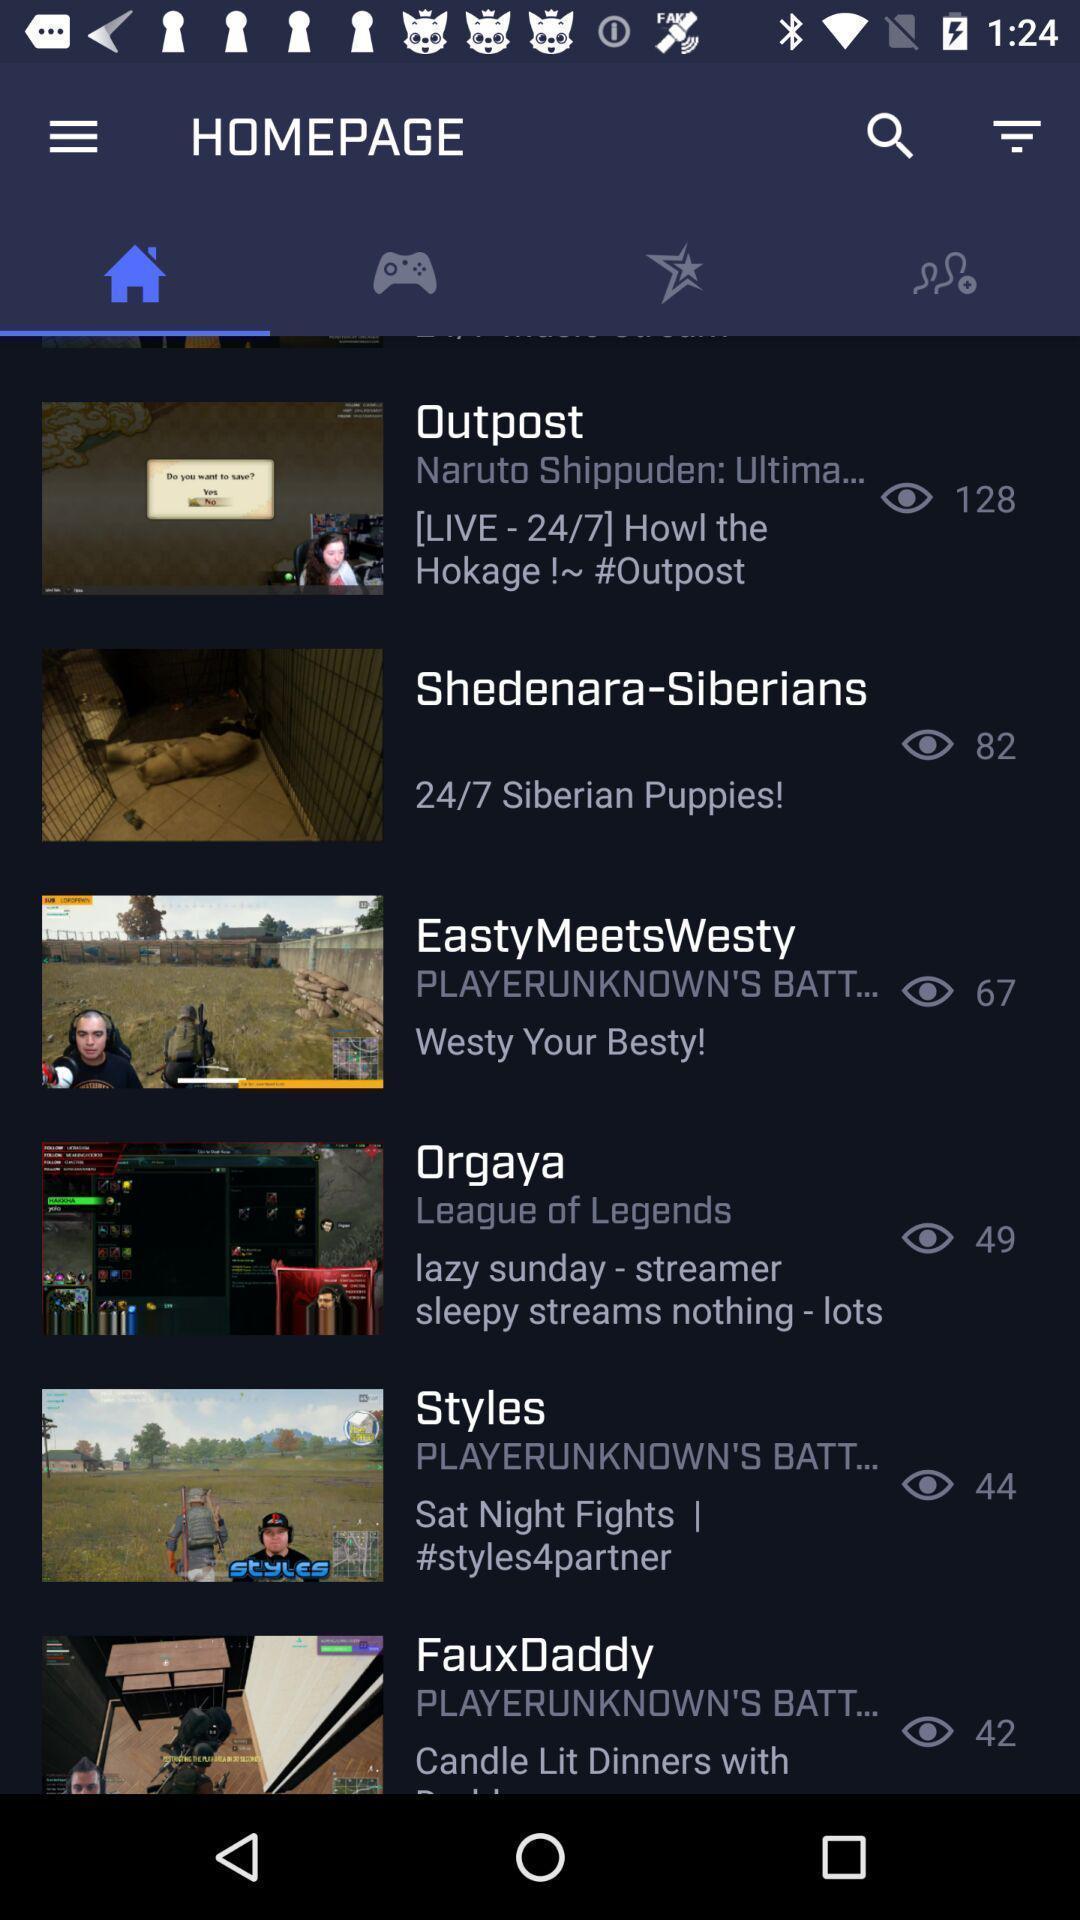Summarize the main components in this picture. Page showing results of various games. 